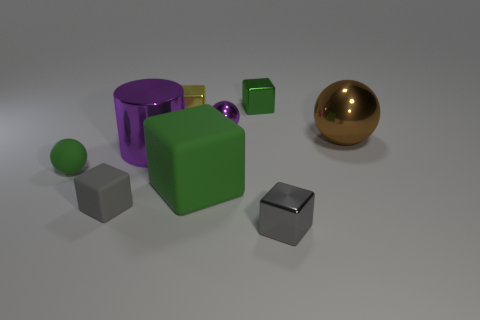Subtract all cyan blocks. Subtract all green cylinders. How many blocks are left? 5 Add 1 shiny cylinders. How many objects exist? 10 Subtract all cylinders. How many objects are left? 8 Subtract 0 green cylinders. How many objects are left? 9 Subtract all tiny rubber things. Subtract all big purple cylinders. How many objects are left? 6 Add 2 tiny green blocks. How many tiny green blocks are left? 3 Add 9 big blue matte balls. How many big blue matte balls exist? 9 